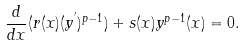Convert formula to latex. <formula><loc_0><loc_0><loc_500><loc_500>\frac { d } { d x } ( r ( x ) ( y ^ { ^ { \prime } } ) ^ { p - 1 } ) + s ( x ) y ^ { p - 1 } ( x ) = 0 .</formula> 